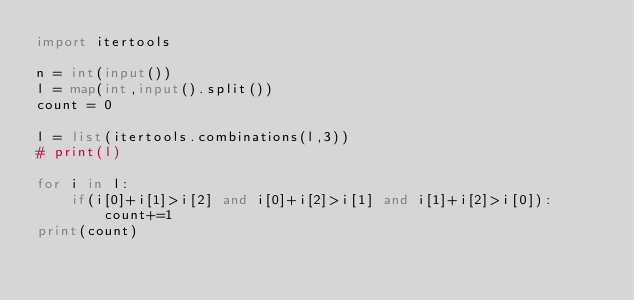<code> <loc_0><loc_0><loc_500><loc_500><_Python_>import itertools

n = int(input())
l = map(int,input().split())
count = 0

l = list(itertools.combinations(l,3))
# print(l)

for i in l:
    if(i[0]+i[1]>i[2] and i[0]+i[2]>i[1] and i[1]+i[2]>i[0]):
        count+=1
print(count)</code> 